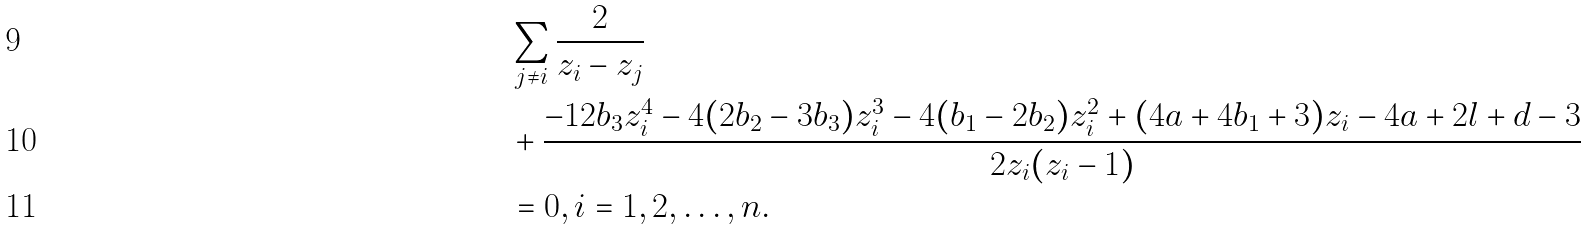Convert formula to latex. <formula><loc_0><loc_0><loc_500><loc_500>& \sum _ { j \ne i } \frac { 2 } { z _ { i } - z _ { j } } \\ & + \frac { - 1 2 b _ { 3 } z _ { i } ^ { 4 } - 4 ( 2 b _ { 2 } - 3 b _ { 3 } ) z _ { i } ^ { 3 } - 4 ( b _ { 1 } - 2 b _ { 2 } ) z _ { i } ^ { 2 } + ( 4 a + 4 b _ { 1 } + 3 ) z _ { i } - 4 a + 2 l + d - 3 } { 2 z _ { i } ( z _ { i } - 1 ) } \\ & = 0 , i = 1 , 2 , \dots , n .</formula> 